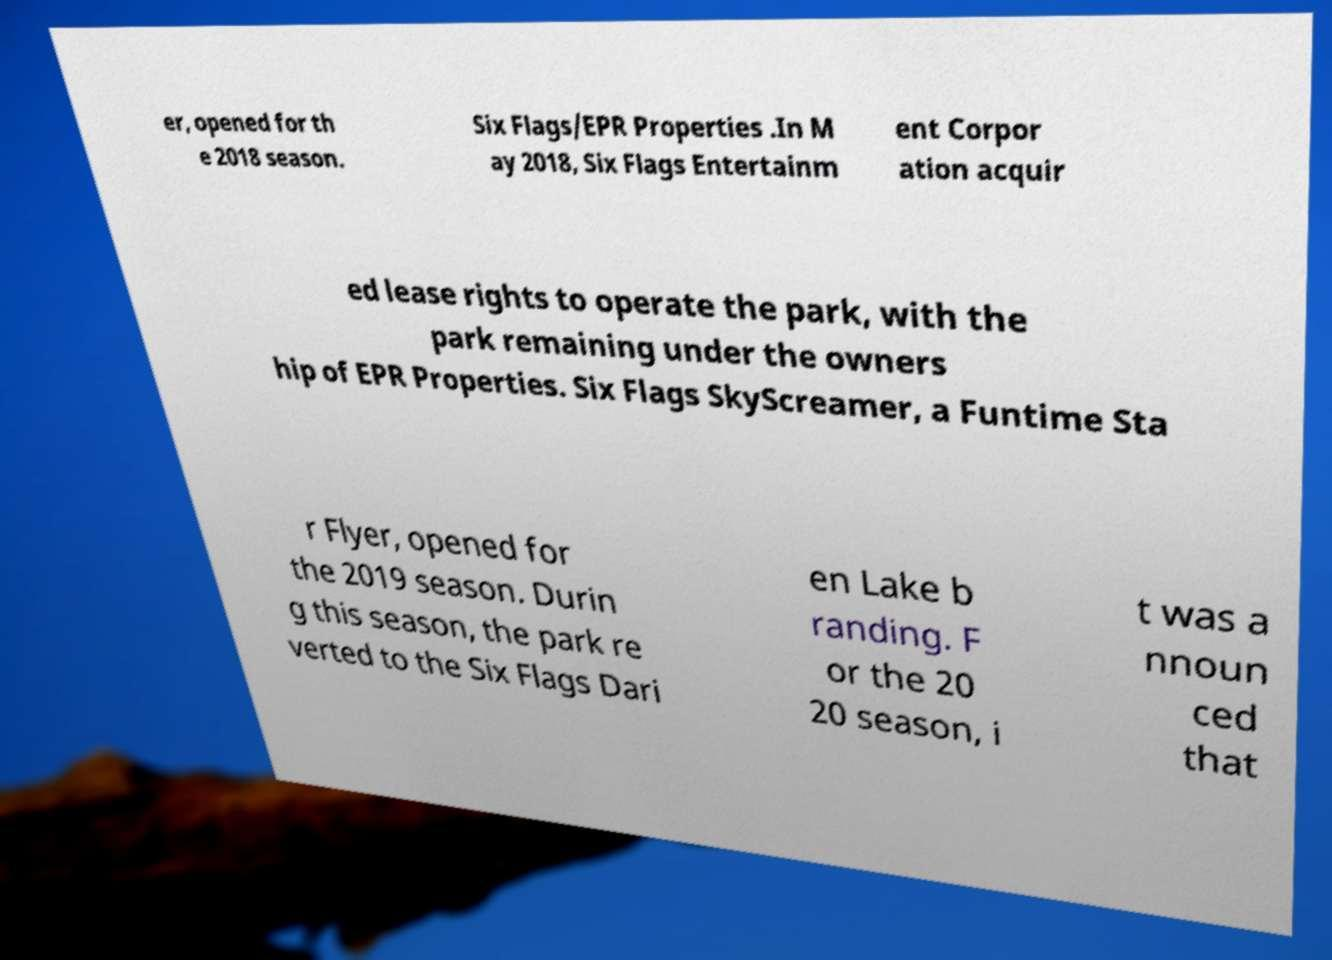There's text embedded in this image that I need extracted. Can you transcribe it verbatim? er, opened for th e 2018 season. Six Flags/EPR Properties .In M ay 2018, Six Flags Entertainm ent Corpor ation acquir ed lease rights to operate the park, with the park remaining under the owners hip of EPR Properties. Six Flags SkyScreamer, a Funtime Sta r Flyer, opened for the 2019 season. Durin g this season, the park re verted to the Six Flags Dari en Lake b randing. F or the 20 20 season, i t was a nnoun ced that 